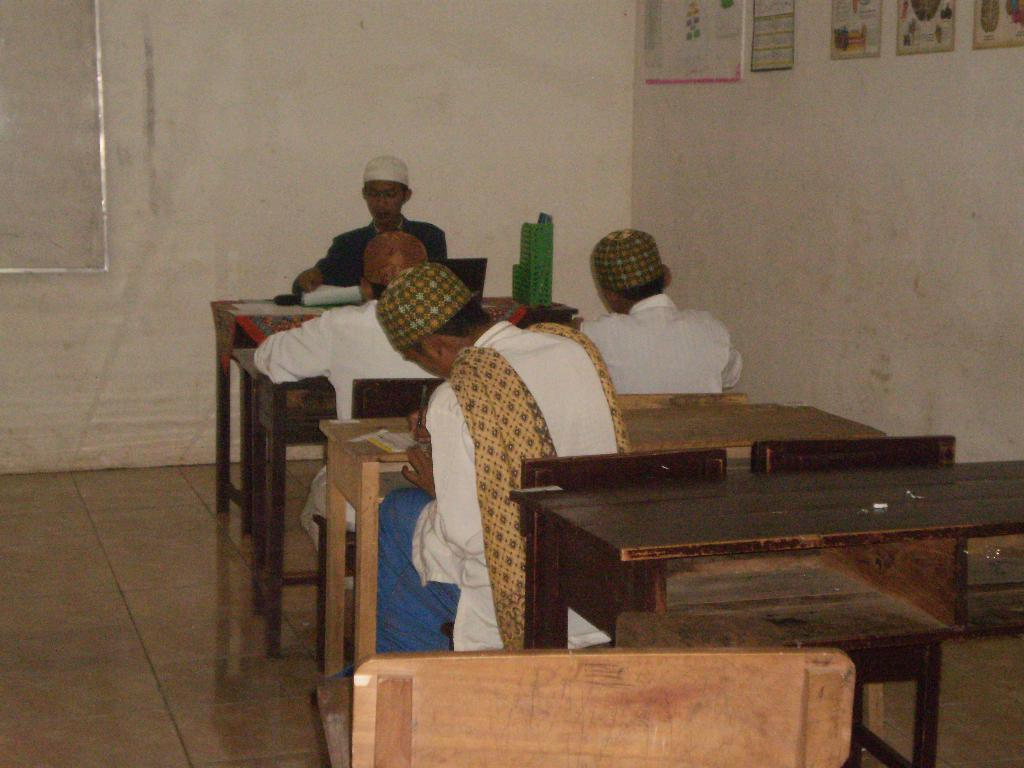What can be seen in the background of the image? There is a wall and a board in the background of the image. What is attached to the wall? There are frames on the wall. What are the boys in the image doing? The boys are sitting on chairs and writing. Where are the boys sitting in relation to the table? The boys are sitting in front of a table. What is the surface depicted in the image? The image depicts a floor. What type of authority figure is present in the image? There is no authority figure present in the image; it depicts boys sitting and writing in front of a table. What kind of badge can be seen on the boys' uniforms in the image? There are no uniforms or badges present in the image. 